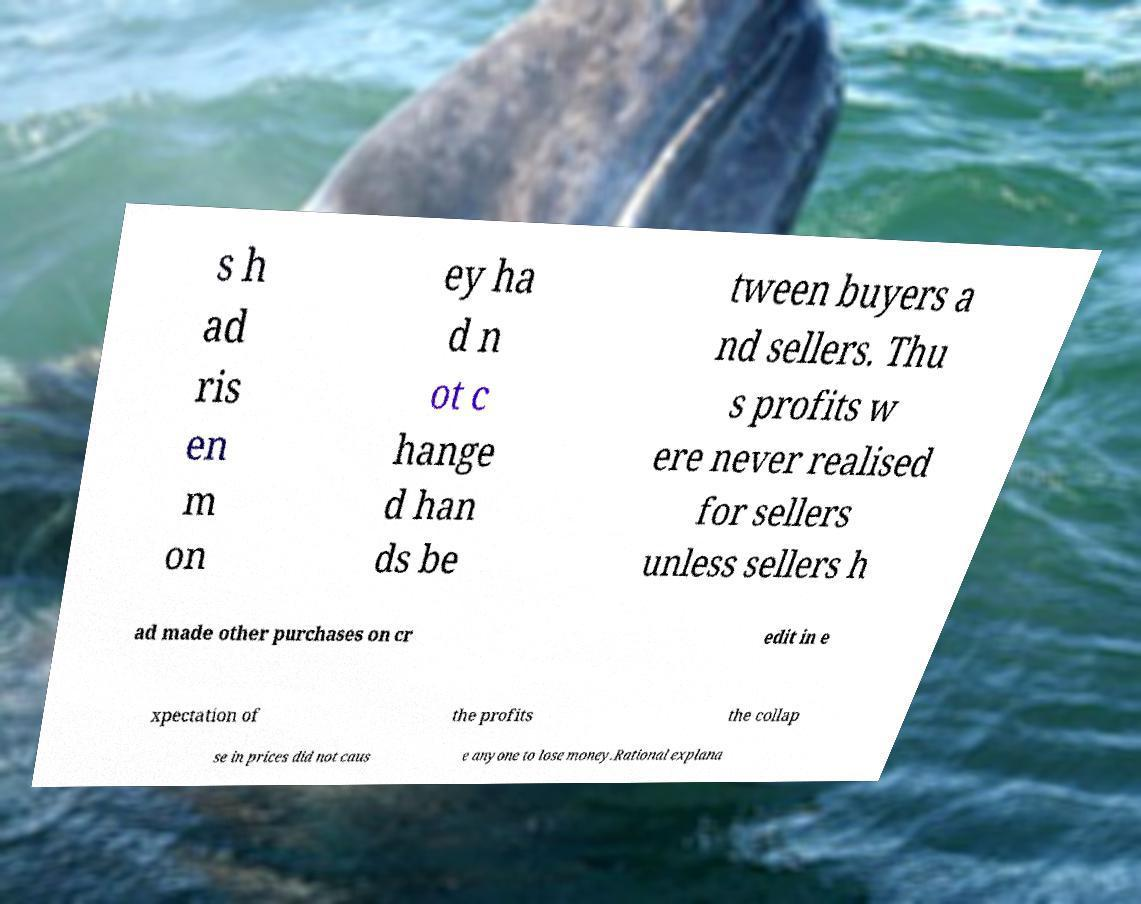I need the written content from this picture converted into text. Can you do that? s h ad ris en m on ey ha d n ot c hange d han ds be tween buyers a nd sellers. Thu s profits w ere never realised for sellers unless sellers h ad made other purchases on cr edit in e xpectation of the profits the collap se in prices did not caus e anyone to lose money.Rational explana 